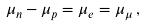Convert formula to latex. <formula><loc_0><loc_0><loc_500><loc_500>\mu _ { n } - \mu _ { p } = \mu _ { e } = \mu _ { \mu } \, ,</formula> 